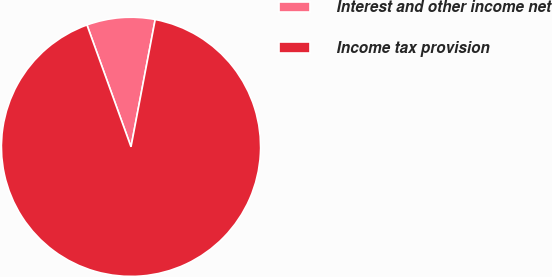<chart> <loc_0><loc_0><loc_500><loc_500><pie_chart><fcel>Interest and other income net<fcel>Income tax provision<nl><fcel>8.51%<fcel>91.49%<nl></chart> 